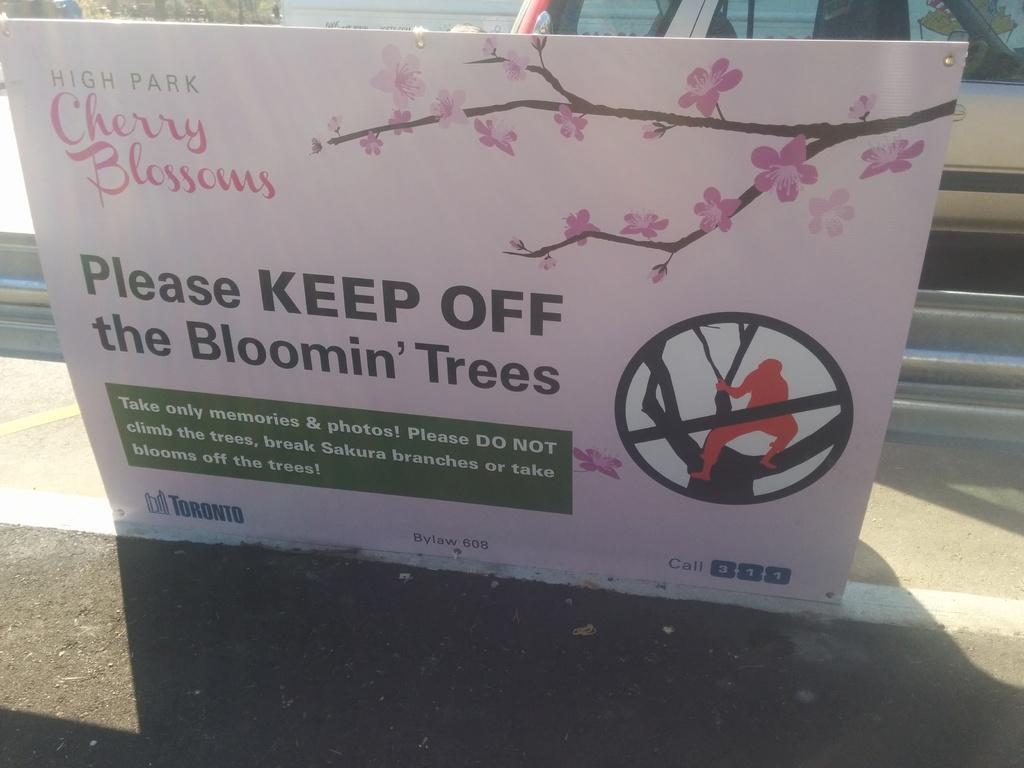What is the main object in the center of the image? There is a banner in the center of the image. What can be found on the banner? There is text on the banner. What can be seen in the background of the image? There is a vehicle and a fence in the background of the image, along with other objects. How many ducks are visible in the image? There are no ducks present in the image. What type of muscle is being exercised by the people in the image? There are no people present in the image, so it is not possible to determine which muscles they might be exercising. 